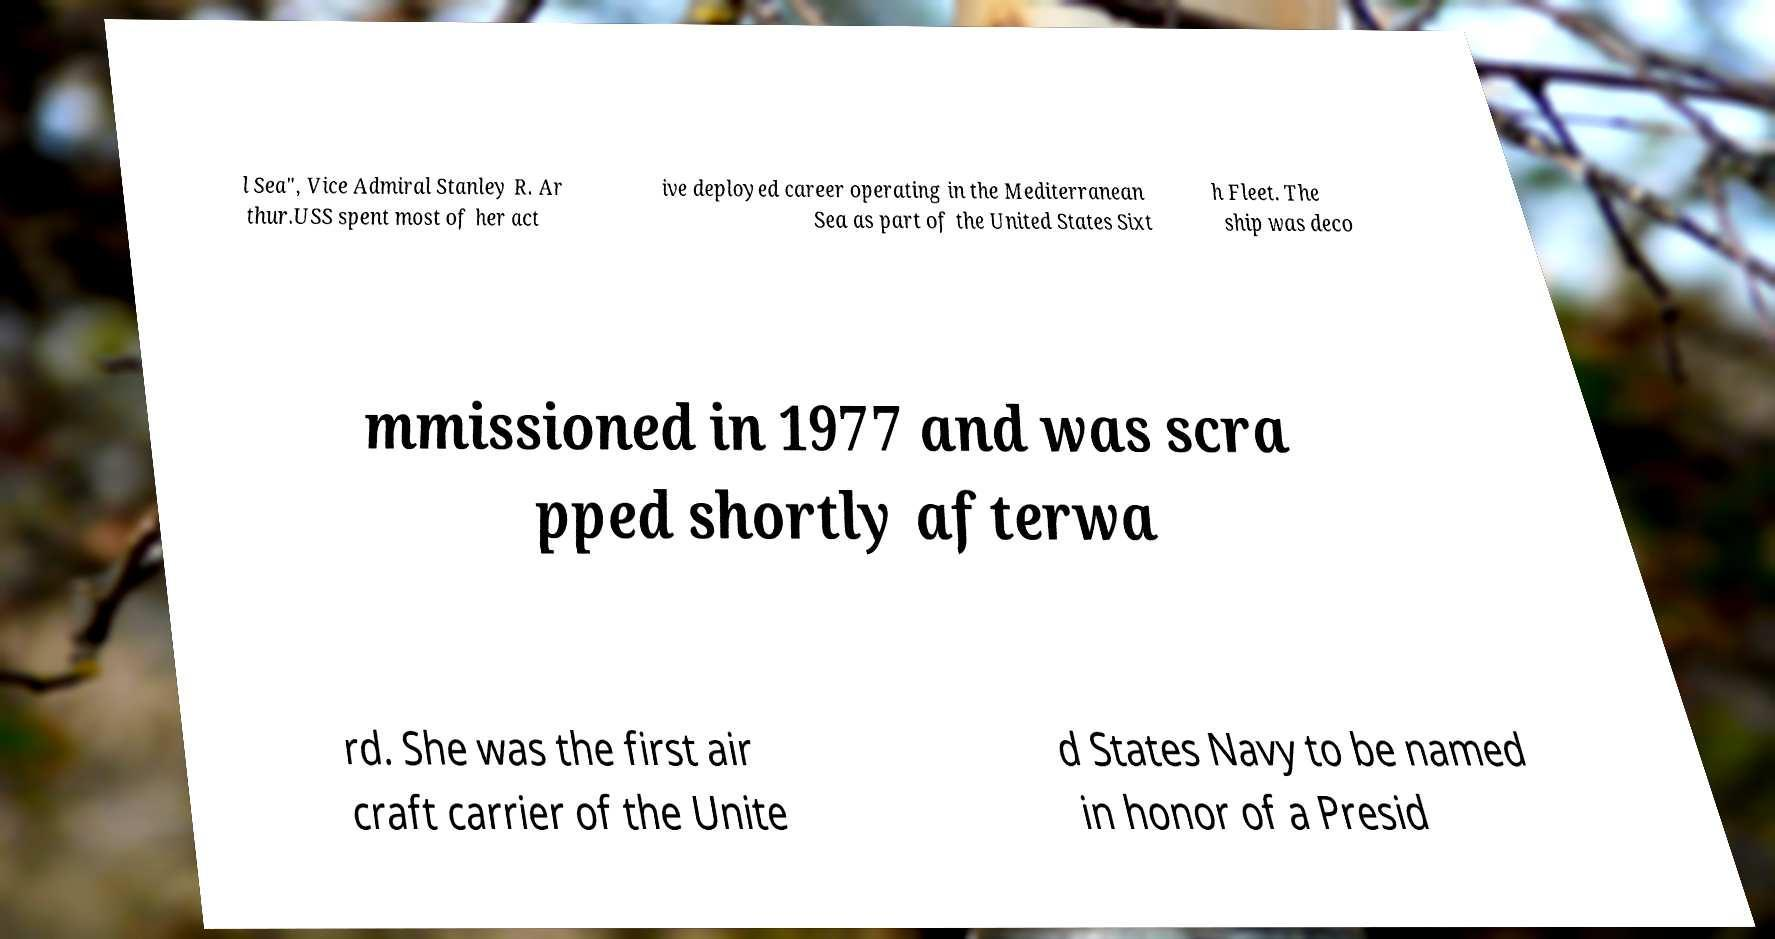Could you assist in decoding the text presented in this image and type it out clearly? l Sea", Vice Admiral Stanley R. Ar thur.USS spent most of her act ive deployed career operating in the Mediterranean Sea as part of the United States Sixt h Fleet. The ship was deco mmissioned in 1977 and was scra pped shortly afterwa rd. She was the first air craft carrier of the Unite d States Navy to be named in honor of a Presid 